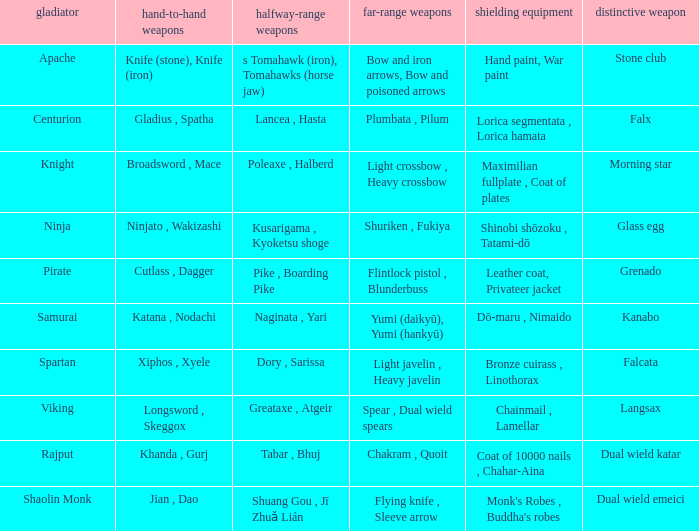If the special weapon is glass egg, what is the close ranged weapon? Ninjato , Wakizashi. 